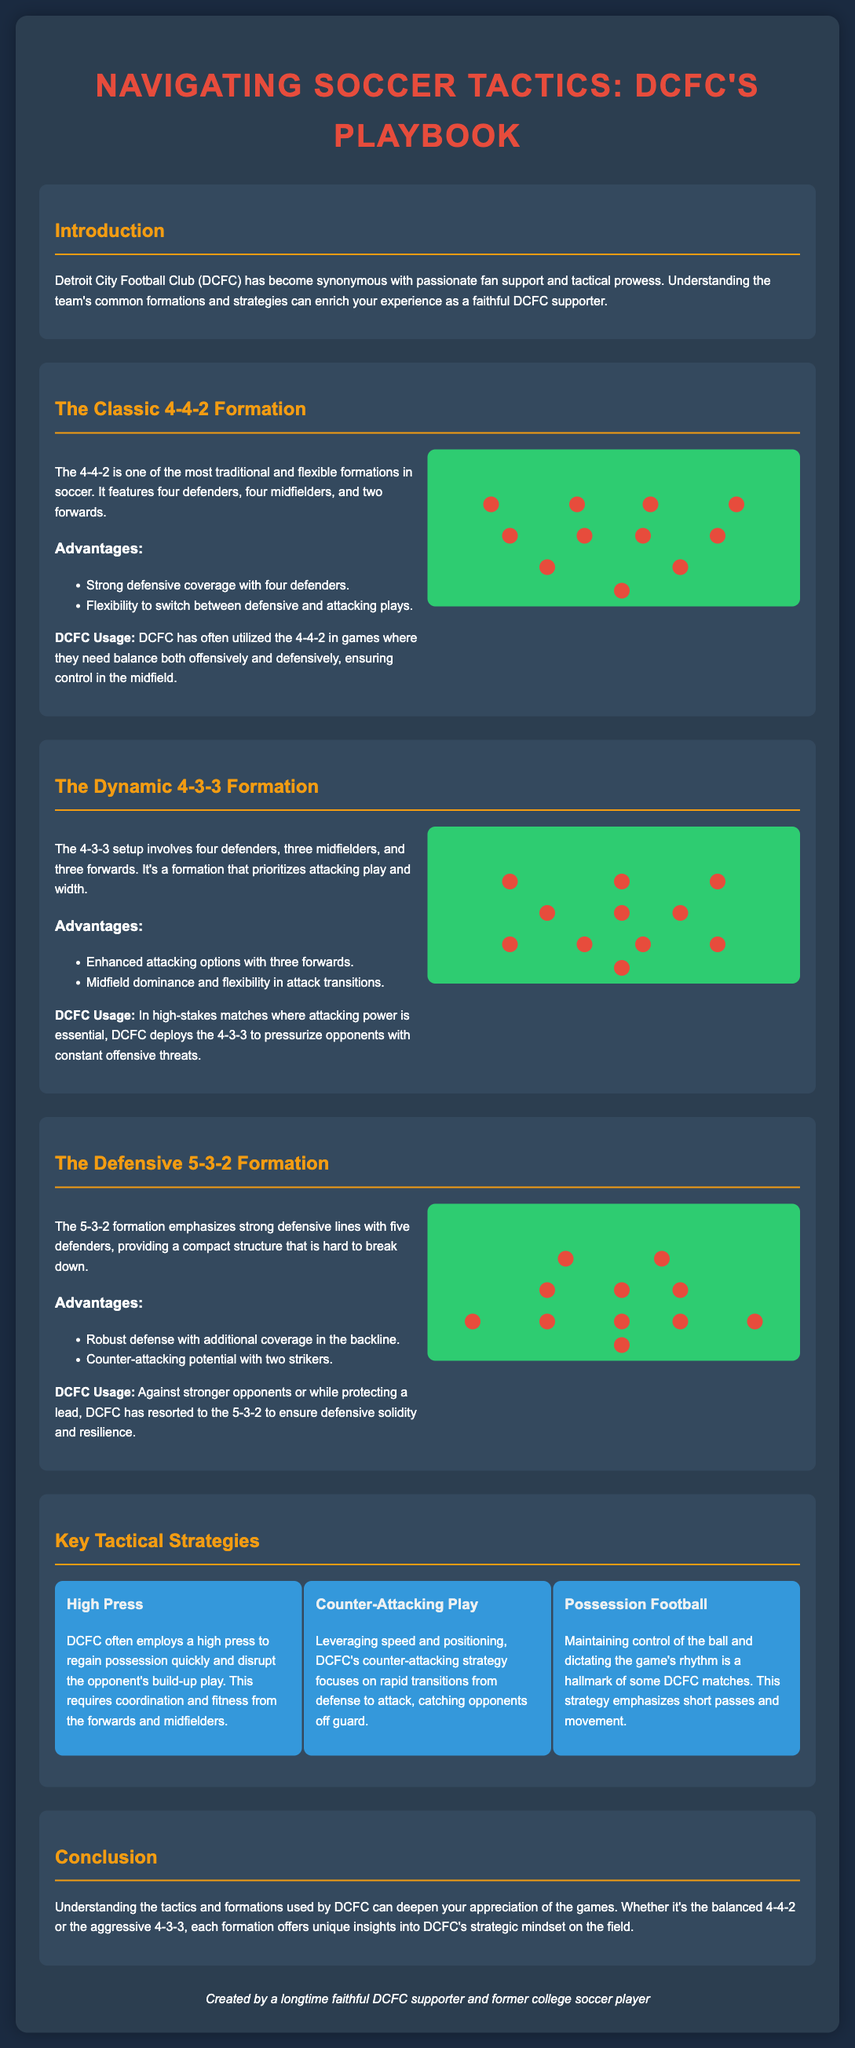What is the title of the document? The title is prominently displayed at the top of the infographic and indicates the main topic of discussion.
Answer: Navigating Soccer Tactics: DCFC's Playbook What is the traditional formation used by DCFC? The document lists specific formations used by DCFC, with the 4-4-2 mentioned as one of the most traditional.
Answer: 4-4-2 How many players are in the 4-3-3 formation? The document specifies the arrangement of players in various formations, with the 4-3-3 having four defenders, three midfielders, and three forwards.
Answer: 10 What strategy focuses on quick ball recovery? The document highlights various tactical strategies employed by DCFC, noting one dedicated to fast regaining possession after losing the ball.
Answer: High Press What formation emphasizes strong defenses? The document explains specific formations and identifies one that is designed for defensive strength with extra players in the backline.
Answer: 5-3-2 Which formation does DCFC use for attacking power? The document notes the purpose behind each formation, indicating one in particular is designed for enhanced attacking capability.
Answer: 4-3-3 How many midfielders are in the 5-3-2 formation? The document outlines the player distribution in the formations, specifically identifying the number of midfielders in the 5-3-2 setup.
Answer: 3 What is a hallmark of DCFC’s possession strategy? The document discusses key tactical strategies and mentions a characteristic that defines their approach when controlling the ball.
Answer: Short passes What is the color scheme of the infographic? The design choices such as background and text colors are described in the document, indicating the overall aesthetic appeal.
Answer: Dark blue and red 